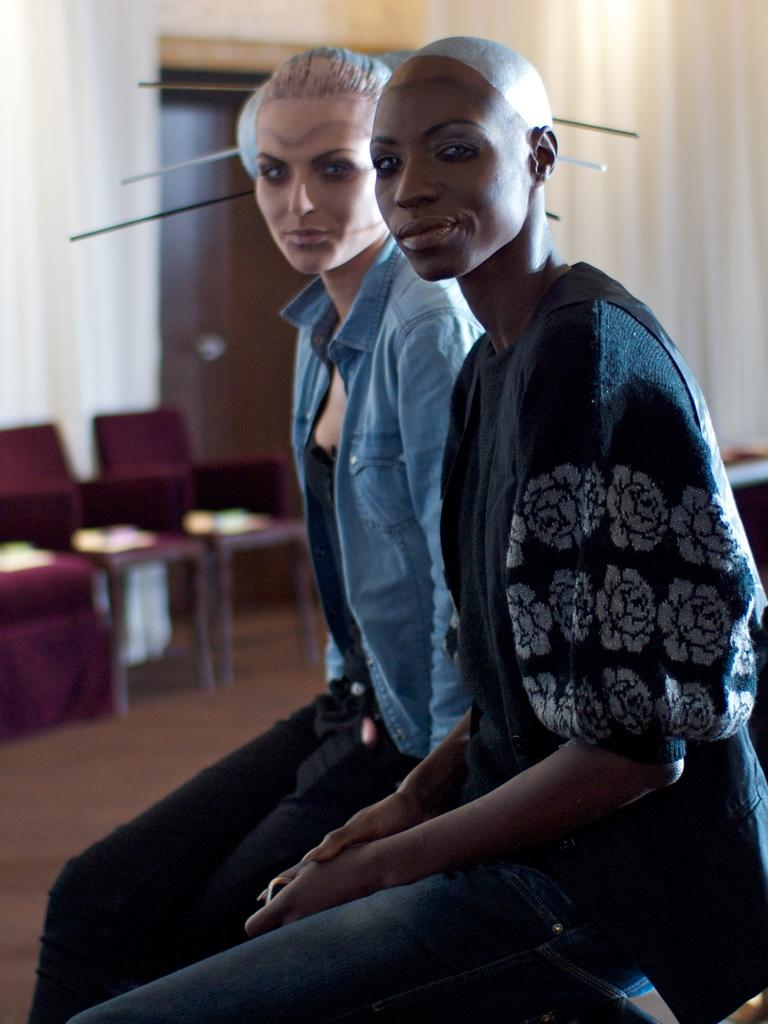How many women are in the image? There are two women in the image. What are the women doing in the image? The women are sitting in the image. What are the women wearing in the image? The women are wearing jackets in the image. Can you describe the chairs in the image? There are maroon-colored chairs in the image, and they are on the floor. What type of business or organization does the image represent? The image does not represent any specific business or organization; it simply shows two women sitting on chairs. 